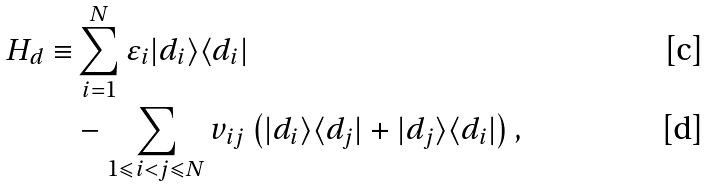<formula> <loc_0><loc_0><loc_500><loc_500>H _ { d } \equiv & \sum _ { i = 1 } ^ { N } \varepsilon _ { i } | d _ { i } \rangle \langle d _ { i } | \\ & - \sum _ { 1 \leqslant i < j \leqslant N } v _ { i j } \left ( | d _ { i } \rangle \langle d _ { j } | + | d _ { j } \rangle \langle d _ { i } | \right ) ,</formula> 